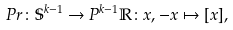<formula> <loc_0><loc_0><loc_500><loc_500>P r \colon \mathbb { S } ^ { k - 1 } \rightarrow P ^ { k - 1 } \mathbb { R } \colon x , - x \mapsto [ x ] ,</formula> 